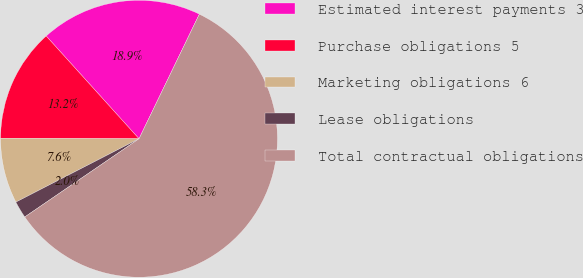<chart> <loc_0><loc_0><loc_500><loc_500><pie_chart><fcel>Estimated interest payments 3<fcel>Purchase obligations 5<fcel>Marketing obligations 6<fcel>Lease obligations<fcel>Total contractual obligations<nl><fcel>18.87%<fcel>13.25%<fcel>7.62%<fcel>1.99%<fcel>58.27%<nl></chart> 